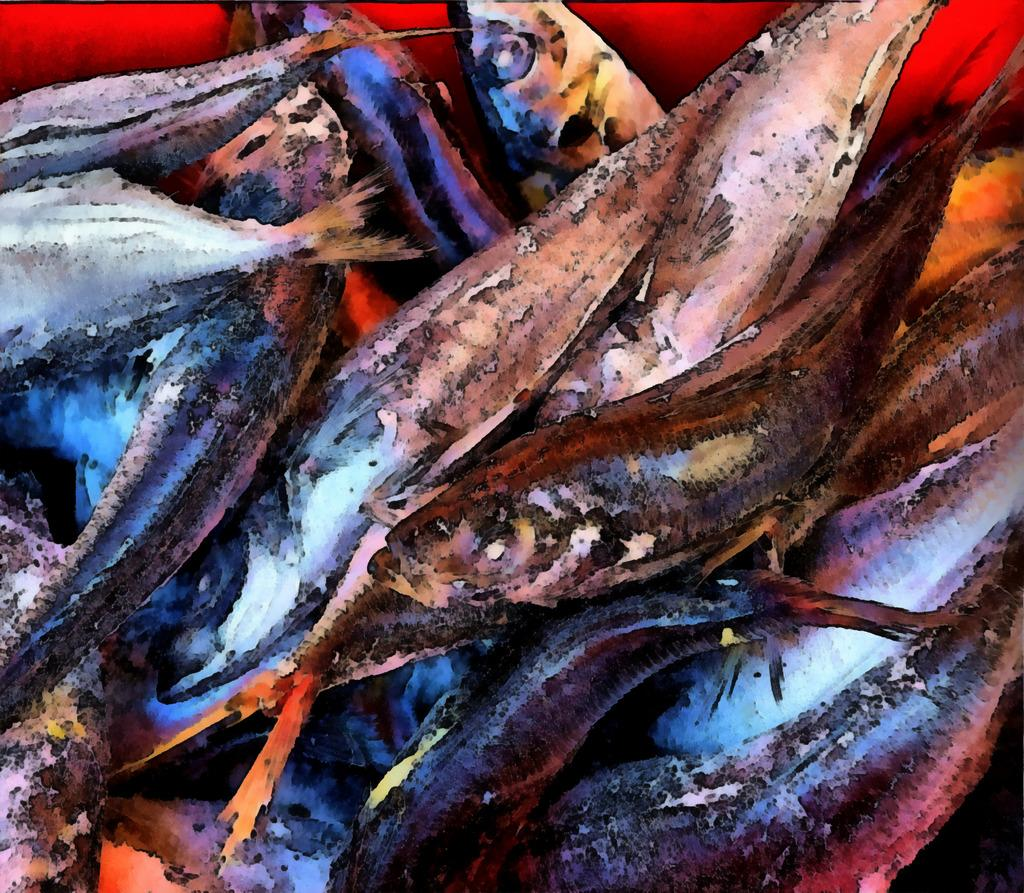What type of animals can be seen in the image? There is a group of fish in the image. Can you describe the setting where the fish are located? The image does not provide information about the setting, only that there is a group of fish present. How many fish are visible in the image? The number of fish is not specified in the provided facts, so it cannot be determined from the image. What type of faucet can be seen in the image? There is no faucet present in the image; it features a group of fish. Can you hear the sound of a horn in the image? There is no sound or indication of a horn in the image, as it is a still image of a group of fish. 